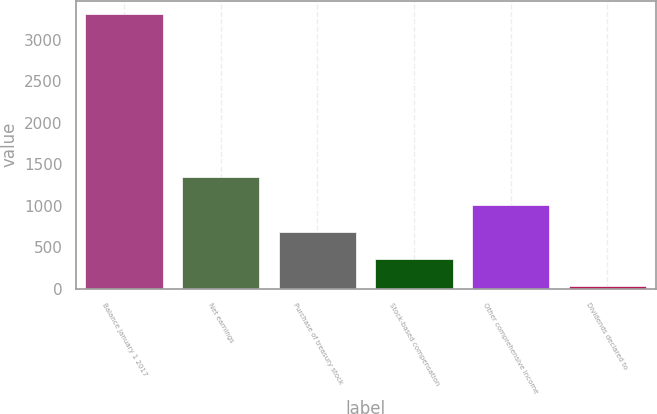Convert chart. <chart><loc_0><loc_0><loc_500><loc_500><bar_chart><fcel>Balance January 1 2017<fcel>Net earnings<fcel>Purchase of treasury stock<fcel>Stock-based compensation<fcel>Other comprehensive income<fcel>Dividends declared to<nl><fcel>3301.9<fcel>1338.34<fcel>683.82<fcel>356.56<fcel>1011.08<fcel>29.3<nl></chart> 